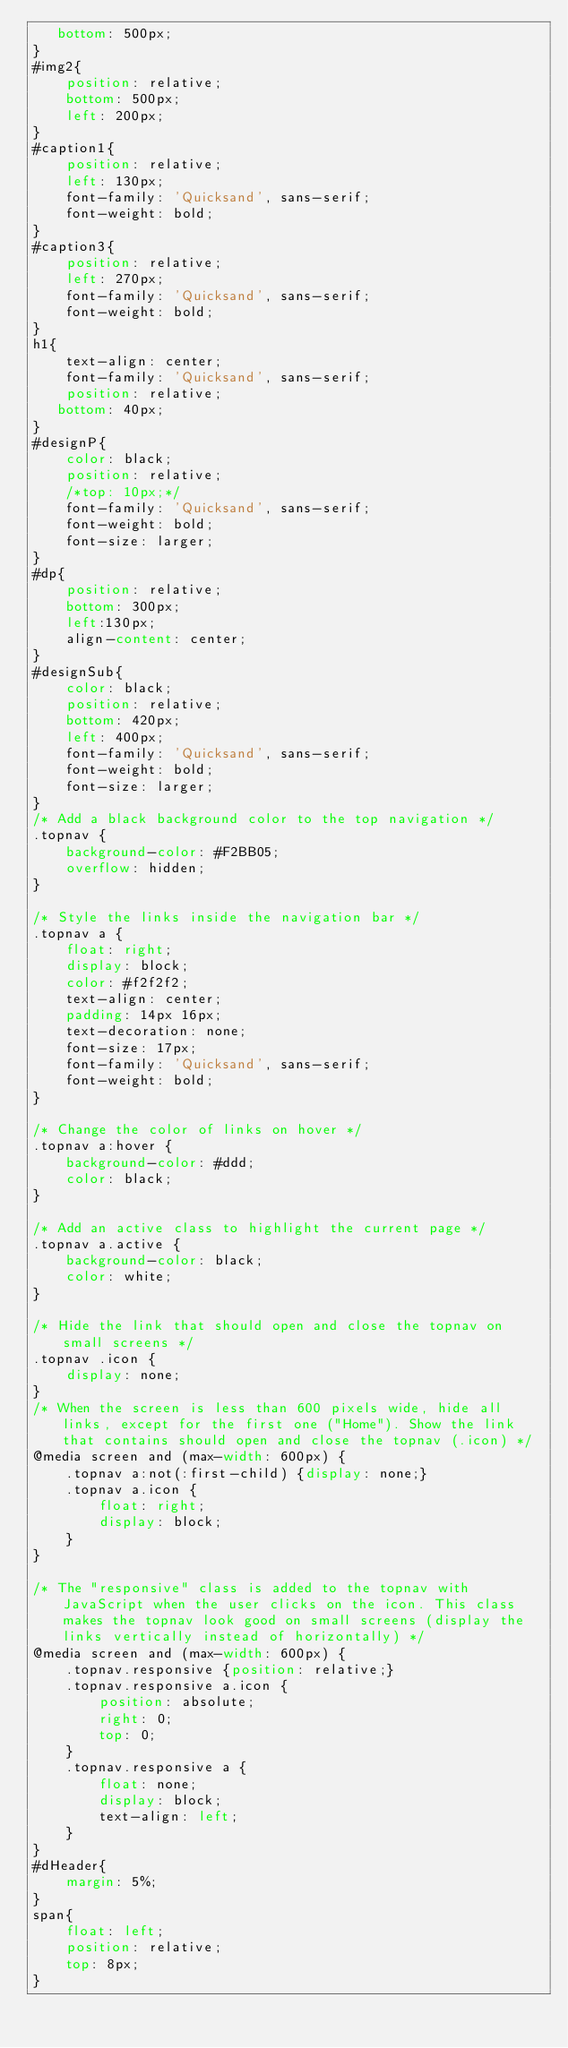<code> <loc_0><loc_0><loc_500><loc_500><_CSS_>   bottom: 500px;
}
#img2{
    position: relative;
    bottom: 500px;
    left: 200px;
}
#caption1{
    position: relative;
    left: 130px;
    font-family: 'Quicksand', sans-serif;
    font-weight: bold;
}
#caption3{
    position: relative;
    left: 270px;
    font-family: 'Quicksand', sans-serif;
    font-weight: bold;
}
h1{
    text-align: center;
    font-family: 'Quicksand', sans-serif;
    position: relative;
   bottom: 40px;
}
#designP{
    color: black;
    position: relative;
    /*top: 10px;*/
    font-family: 'Quicksand', sans-serif;
    font-weight: bold;
    font-size: larger;
}
#dp{
    position: relative;
    bottom: 300px;
    left:130px;
    align-content: center;
}
#designSub{
    color: black;
    position: relative;
    bottom: 420px;
    left: 400px;
    font-family: 'Quicksand', sans-serif;
    font-weight: bold;
    font-size: larger;
}
/* Add a black background color to the top navigation */
.topnav {
    background-color: #F2BB05;
    overflow: hidden;
}

/* Style the links inside the navigation bar */
.topnav a {
    float: right;
    display: block;
    color: #f2f2f2;
    text-align: center;
    padding: 14px 16px;
    text-decoration: none;
    font-size: 17px;
    font-family: 'Quicksand', sans-serif;
    font-weight: bold;
}

/* Change the color of links on hover */
.topnav a:hover {
    background-color: #ddd;
    color: black;
}

/* Add an active class to highlight the current page */
.topnav a.active {
    background-color: black;
    color: white;
}

/* Hide the link that should open and close the topnav on small screens */
.topnav .icon {
    display: none;
}
/* When the screen is less than 600 pixels wide, hide all links, except for the first one ("Home"). Show the link that contains should open and close the topnav (.icon) */
@media screen and (max-width: 600px) {
    .topnav a:not(:first-child) {display: none;}
    .topnav a.icon {
        float: right;
        display: block;
    }
}

/* The "responsive" class is added to the topnav with JavaScript when the user clicks on the icon. This class makes the topnav look good on small screens (display the links vertically instead of horizontally) */
@media screen and (max-width: 600px) {
    .topnav.responsive {position: relative;}
    .topnav.responsive a.icon {
        position: absolute;
        right: 0;
        top: 0;
    }
    .topnav.responsive a {
        float: none;
        display: block;
        text-align: left;
    }
}
#dHeader{
    margin: 5%;
}
span{
    float: left;
    position: relative;
    top: 8px;
}</code> 